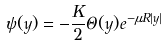<formula> <loc_0><loc_0><loc_500><loc_500>\psi ( y ) = - \frac { K } { 2 } \Theta ( y ) e ^ { - \mu R | y | }</formula> 